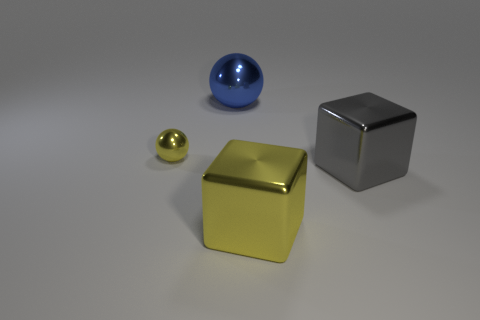How many other things are the same shape as the tiny yellow object?
Ensure brevity in your answer.  1. What is the shape of the big shiny object that is in front of the large gray shiny object?
Make the answer very short. Cube. There is a big metallic thing in front of the large gray cube; does it have the same shape as the large object that is to the right of the yellow cube?
Ensure brevity in your answer.  Yes. Are there the same number of metal cubes that are left of the small yellow metal object and large objects?
Offer a terse response. No. Is there anything else that is the same size as the yellow metallic sphere?
Your answer should be compact. No. What is the shape of the metal object that is on the right side of the cube that is left of the big gray cube?
Keep it short and to the point. Cube. Are the cube in front of the gray metal thing and the big gray cube made of the same material?
Provide a short and direct response. Yes. Are there the same number of tiny objects on the right side of the large yellow thing and big metallic cubes on the left side of the large gray object?
Ensure brevity in your answer.  No. There is a big metallic thing that is behind the small thing; what number of big yellow metal objects are left of it?
Your answer should be compact. 0. There is a sphere that is behind the tiny metal thing; does it have the same color as the block that is behind the yellow cube?
Offer a terse response. No. 